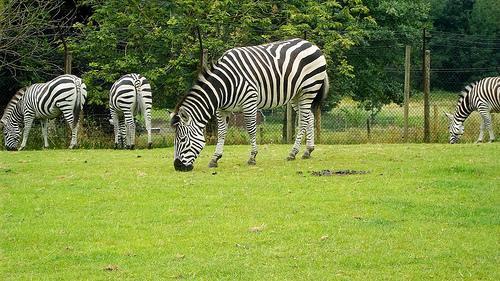How many zebras are there?
Give a very brief answer. 4. How many zebras are shown?
Give a very brief answer. 4. 